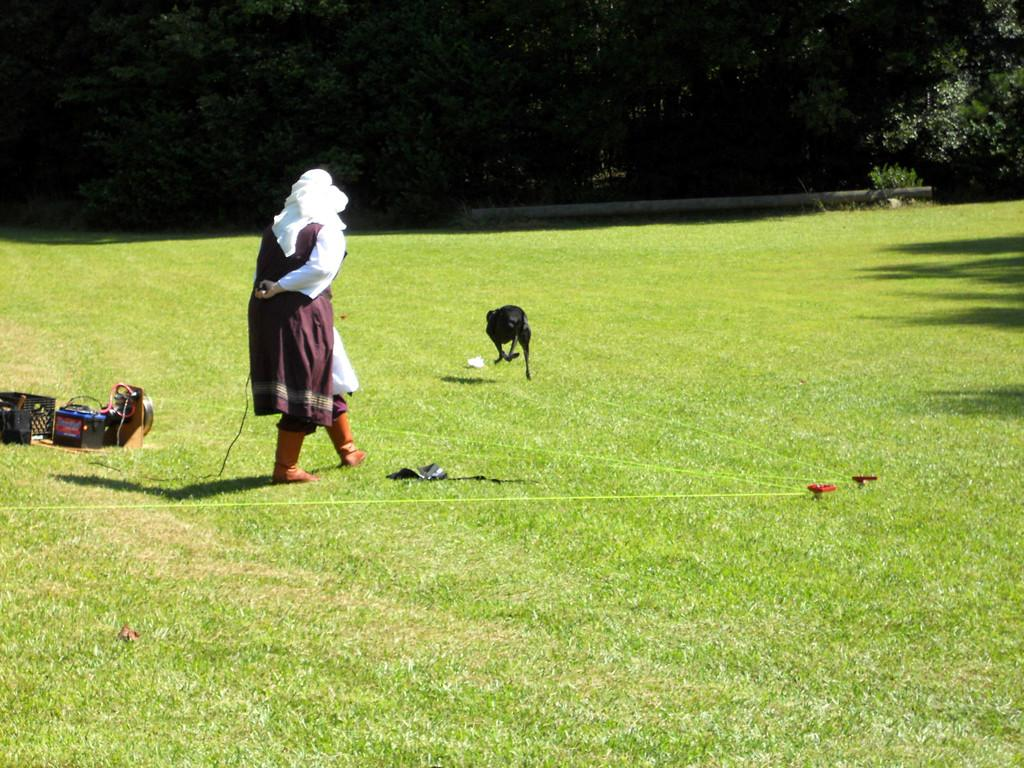What is the main subject in the image? There is a person standing on the ground in the image. Can you describe any other living creature in the image? Yes, there is an animal in the image. What else can be seen in the image besides the person and the animal? There are objects in the image. What can be seen in the background of the image? There are trees in the background of the image. How many dimes can be seen on the person's arm in the image? There are no dimes visible on the person's arm in the image. What type of muscle is the animal using to swim in the image? There is no swimming or muscle activity depicted in the image; it features a person standing on the ground and an animal. 